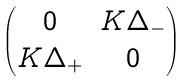Convert formula to latex. <formula><loc_0><loc_0><loc_500><loc_500>\begin{pmatrix} 0 & K \Delta _ { - } \\ K \Delta _ { + } & 0 \end{pmatrix}</formula> 